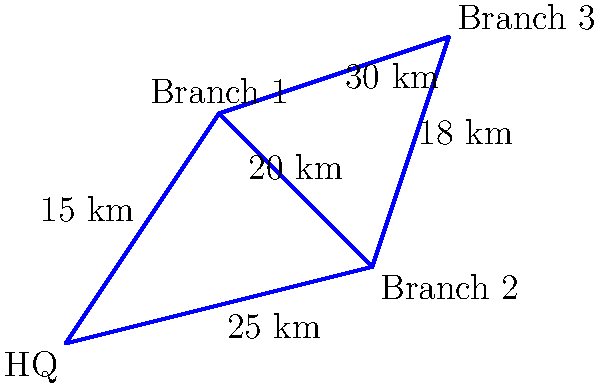As the CIO, you're tasked with designing the most cost-effective fiber optic network to connect the company's headquarters (HQ) with three branch locations. The diagram shows the distances between locations. What is the minimum total length of fiber optic cable required to ensure all locations are connected, either directly or indirectly? To find the most cost-effective solution, we need to determine the minimum spanning tree of the network. This will connect all locations with the least total cable length. Let's follow these steps:

1. List all possible connections and their distances:
   HQ to Branch 1: 15 km
   HQ to Branch 2: 25 km
   Branch 1 to Branch 2: 20 km
   Branch 1 to Branch 3: 30 km
   Branch 2 to Branch 3: 18 km

2. Apply Kruskal's algorithm to find the minimum spanning tree:
   a. Sort connections by distance (ascending):
      HQ to Branch 1: 15 km
      Branch 2 to Branch 3: 18 km
      Branch 1 to Branch 2: 20 km
      HQ to Branch 2: 25 km
      Branch 1 to Branch 3: 30 km

   b. Add connections, avoiding cycles:
      - Add HQ to Branch 1 (15 km)
      - Add Branch 2 to Branch 3 (18 km)
      - Add Branch 1 to Branch 2 (20 km)

3. The minimum spanning tree is now complete, connecting all locations.

4. Calculate the total length:
   15 km + 18 km + 20 km = 53 km

Therefore, the minimum total length of fiber optic cable required to connect all locations is 53 km.
Answer: 53 km 